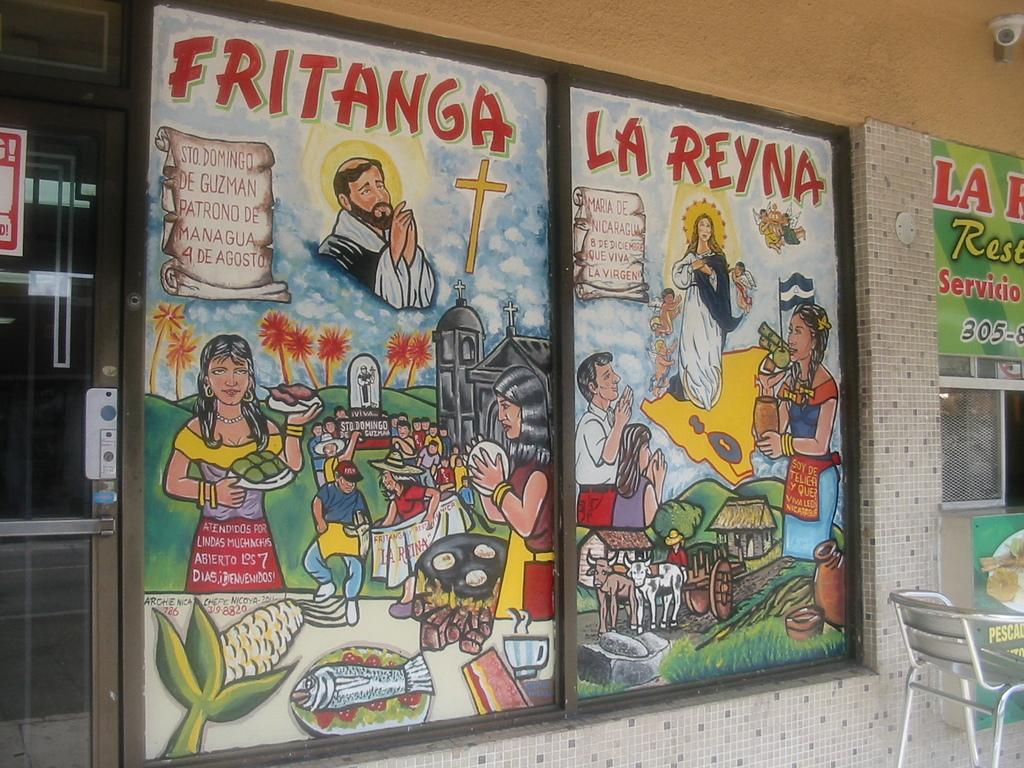Provide a one-sentence caption for the provided image. Artwork that says, "Fritanga, La Reyna" is posted on a window. 